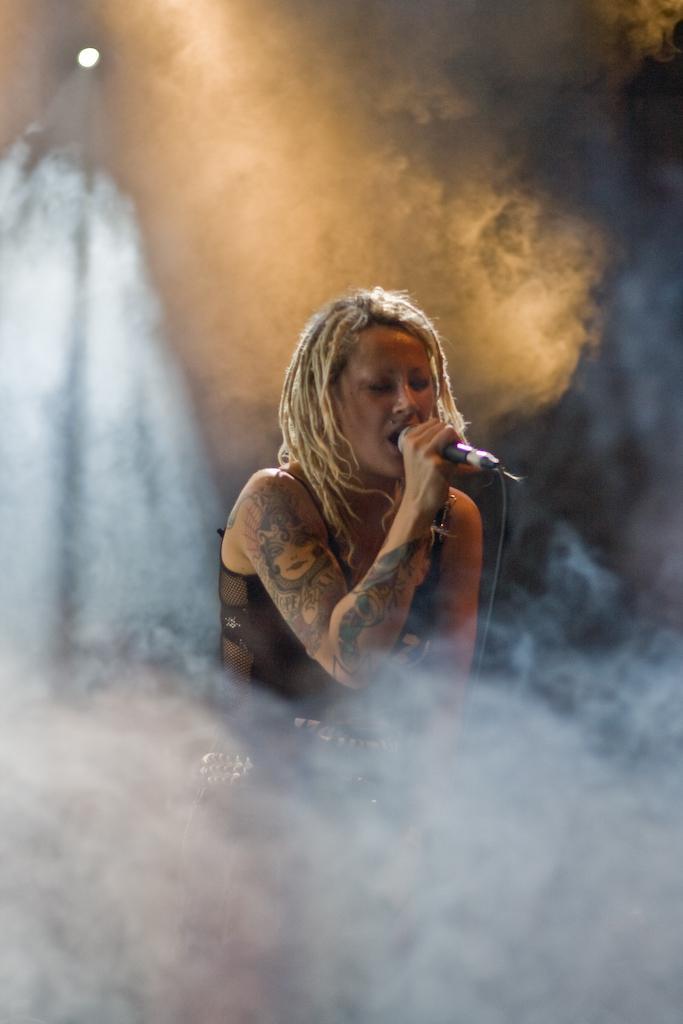Can you describe this image briefly? There is a woman holding mic and singing. There is smoke. At the top there is a light. 